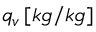<formula> <loc_0><loc_0><loc_500><loc_500>q _ { v } \, [ k g / k g ]</formula> 